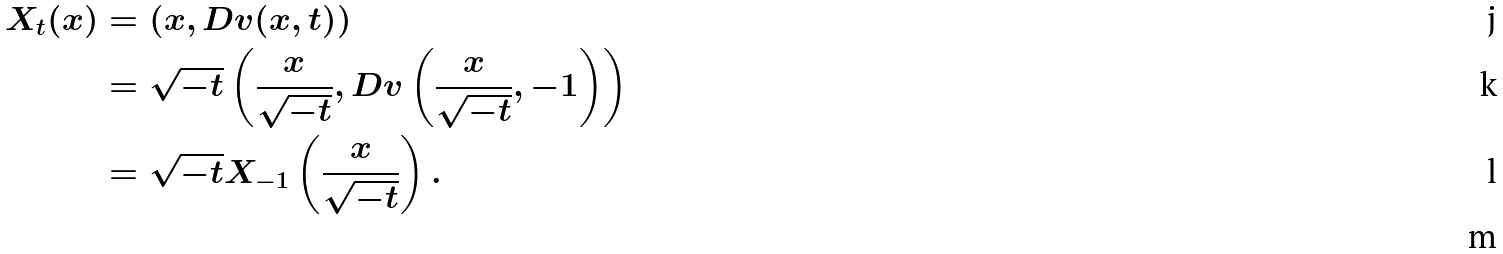Convert formula to latex. <formula><loc_0><loc_0><loc_500><loc_500>X _ { t } ( x ) & = ( x , D v ( x , t ) ) \\ & = \sqrt { - t } \left ( \frac { x } { \sqrt { - t } } , D v \left ( \frac { x } { \sqrt { - t } } , - 1 \right ) \right ) \\ & = \sqrt { - t } X _ { - 1 } \left ( \frac { x } { \sqrt { - t } } \right ) . \\</formula> 